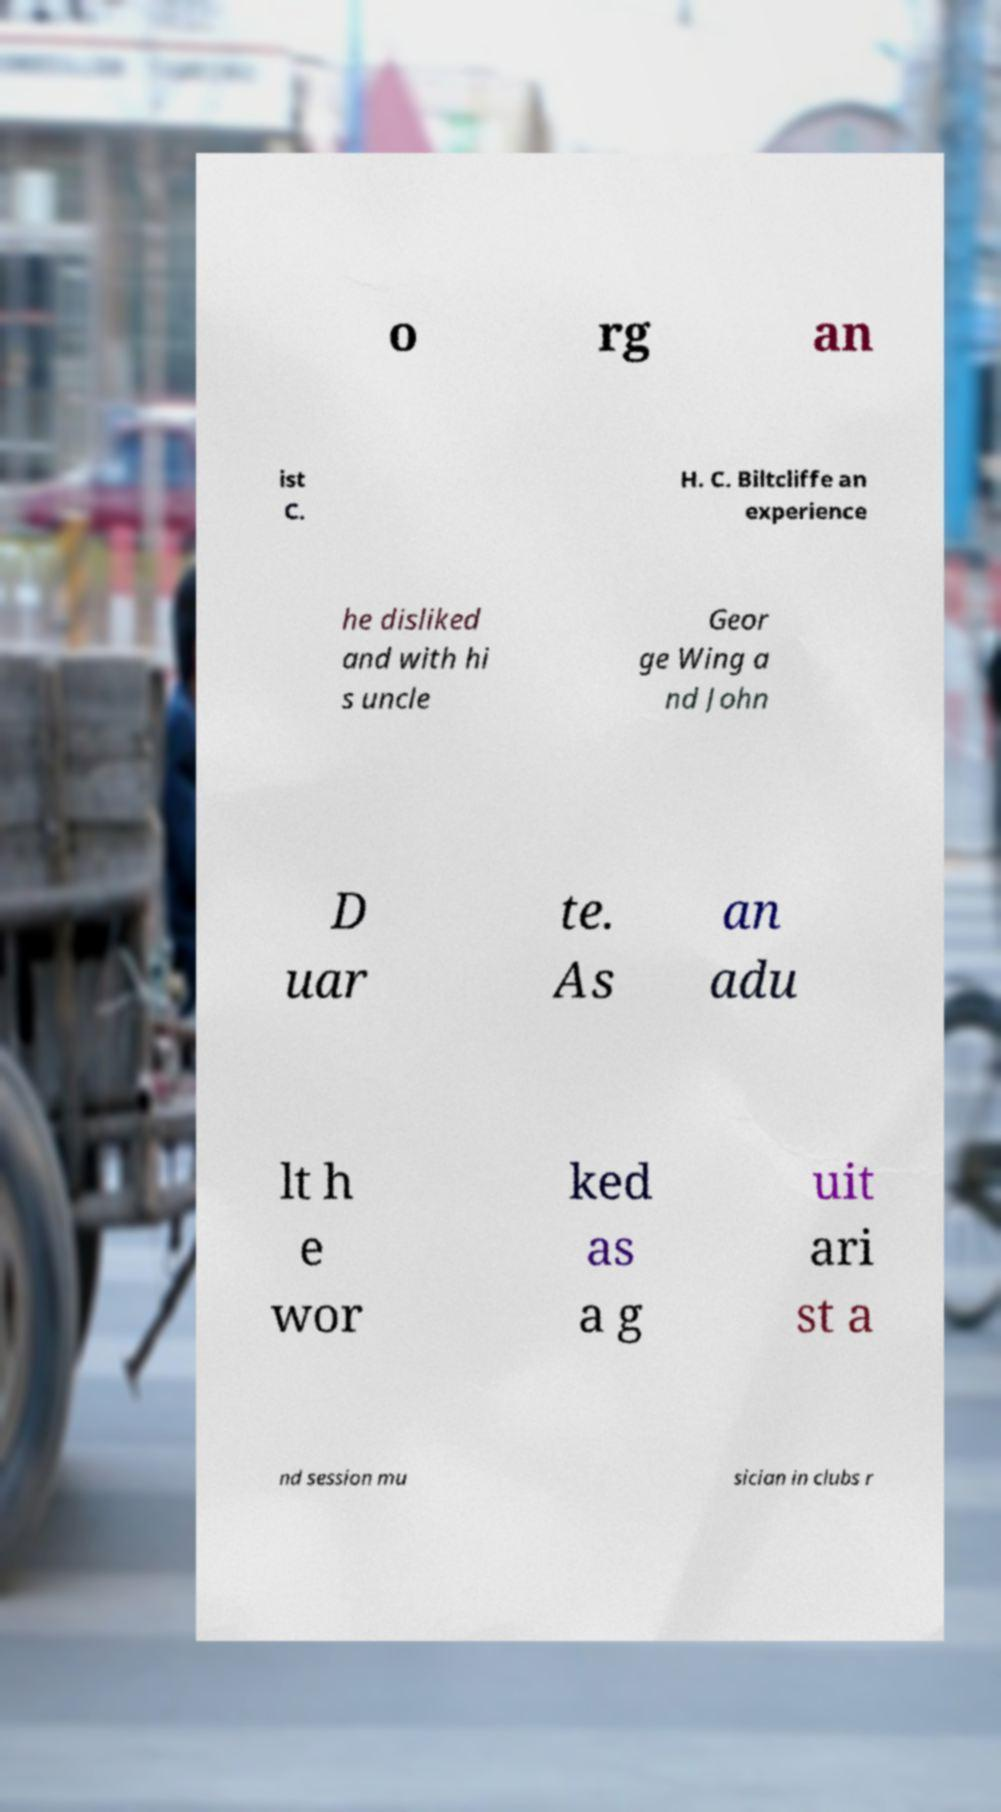Can you read and provide the text displayed in the image?This photo seems to have some interesting text. Can you extract and type it out for me? o rg an ist C. H. C. Biltcliffe an experience he disliked and with hi s uncle Geor ge Wing a nd John D uar te. As an adu lt h e wor ked as a g uit ari st a nd session mu sician in clubs r 